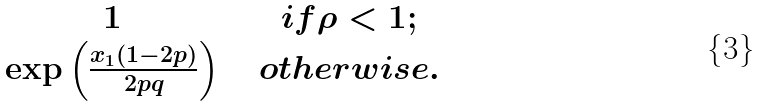<formula> <loc_0><loc_0><loc_500><loc_500>\begin{matrix} 1 \, & & i f \rho < 1 ; \\ \exp \left ( \frac { x _ { 1 } ( 1 - 2 p ) } { 2 p q } \right ) \, & & o t h e r w i s e . \end{matrix}</formula> 